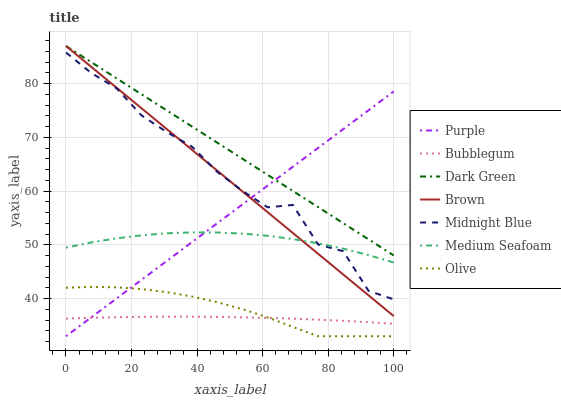Does Bubblegum have the minimum area under the curve?
Answer yes or no. Yes. Does Dark Green have the maximum area under the curve?
Answer yes or no. Yes. Does Midnight Blue have the minimum area under the curve?
Answer yes or no. No. Does Midnight Blue have the maximum area under the curve?
Answer yes or no. No. Is Dark Green the smoothest?
Answer yes or no. Yes. Is Midnight Blue the roughest?
Answer yes or no. Yes. Is Purple the smoothest?
Answer yes or no. No. Is Purple the roughest?
Answer yes or no. No. Does Purple have the lowest value?
Answer yes or no. Yes. Does Midnight Blue have the lowest value?
Answer yes or no. No. Does Dark Green have the highest value?
Answer yes or no. Yes. Does Midnight Blue have the highest value?
Answer yes or no. No. Is Medium Seafoam less than Dark Green?
Answer yes or no. Yes. Is Dark Green greater than Medium Seafoam?
Answer yes or no. Yes. Does Purple intersect Brown?
Answer yes or no. Yes. Is Purple less than Brown?
Answer yes or no. No. Is Purple greater than Brown?
Answer yes or no. No. Does Medium Seafoam intersect Dark Green?
Answer yes or no. No. 